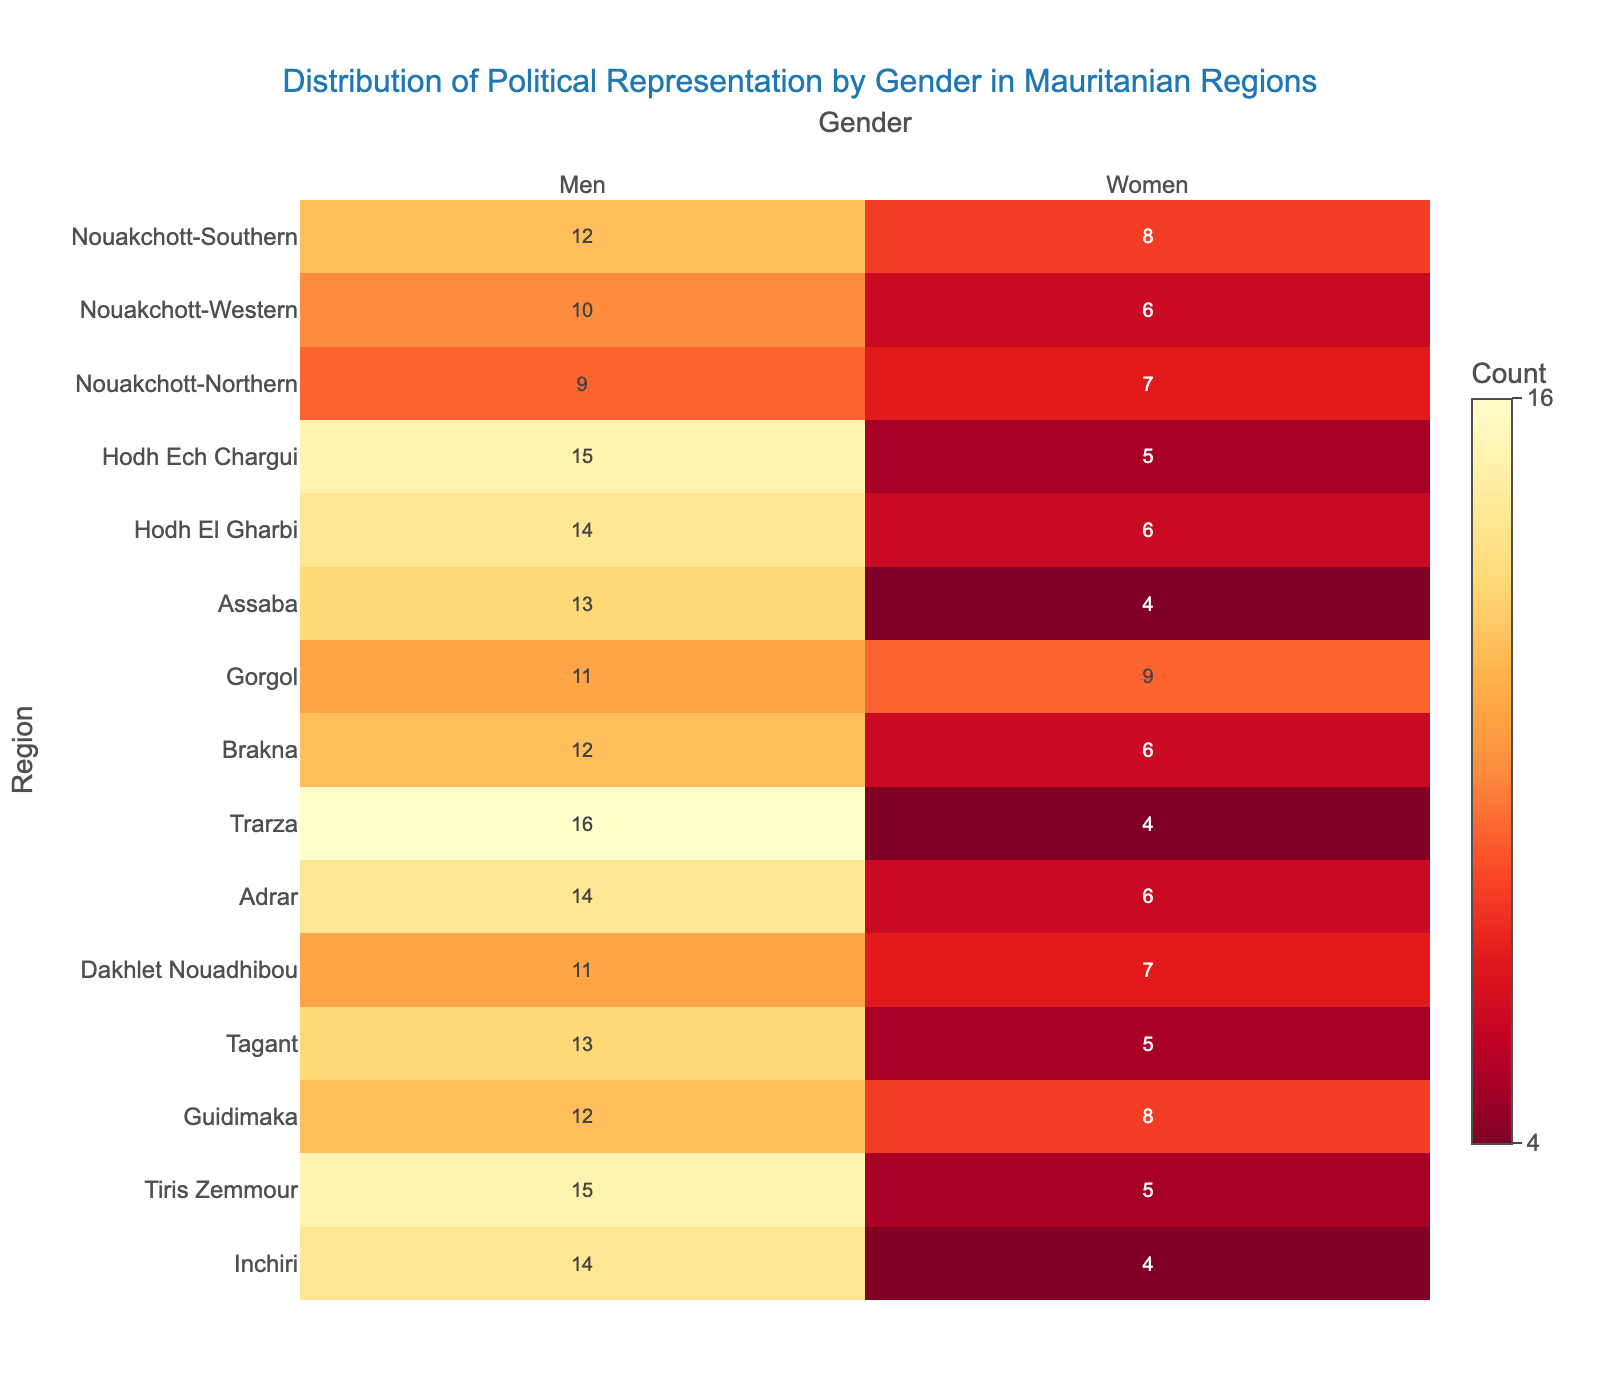What is the title of the heatmap? The title of the heatmap is displayed prominently at the top to give an overview of what the figure is about.
Answer: Distribution of Political Representation by Gender in Mauritanian Regions Which region has the highest number of men? To determine the region with the highest number of men, locate the column for 'Men' and find the region with the highest count. Trarza has a count of 16 men.
Answer: Trarza Which region has the most balanced representation between men and women? To find the most balanced representation, compare the counts of men and women within each region to see which region has the smallest difference. Nouakchott-Northern has the smallest difference with 9 men and 7 women.
Answer: Nouakchott-Northern How many regions have more than 10 men representatives? Count the number of regions where the 'Men' column has values greater than 10. There are 11 regions with more than 10 men representatives.
Answer: 11 What's the average number of women representatives across all regions? Add up the number of women representatives in all regions and divide by the number of regions (15). The sum of women representatives is 95, so the average is 95/15 = 6.33.
Answer: 6.33 Which two regions have the highest total political representation (sum of men and women)? For each region, add the counts of men and women. Compare the sums to find the two regions with the highest totals. Trarza (16+4=20) and Hodh Ech Chargui (15+5=20) have the highest totals.
Answer: Trarza and Hodh Ech Chargui What is the difference in the number of men and women in Nouakchott-Southern? Subtract the number of women from the number of men in Nouakchott-Southern. The difference is 12 - 8 = 4.
Answer: 4 Which gender has greater representation in Guidimaka? Compare the values for men and women in Guidimaka. There are 12 men and 8 women, so men have greater representation.
Answer: Men What's the total number of political representatives in regions starting with 'Hodh'? Add the counts of men and women in Hodh Ech Chargui and Hodh El Gharbi. The total is (15+5) + (14+6) = 40.
Answer: 40 What range of values does the color bar represent? The color bar ranges from the minimum to the maximum count of representatives. The minimum count is 4, and the maximum count is 16.
Answer: 4 to 16 